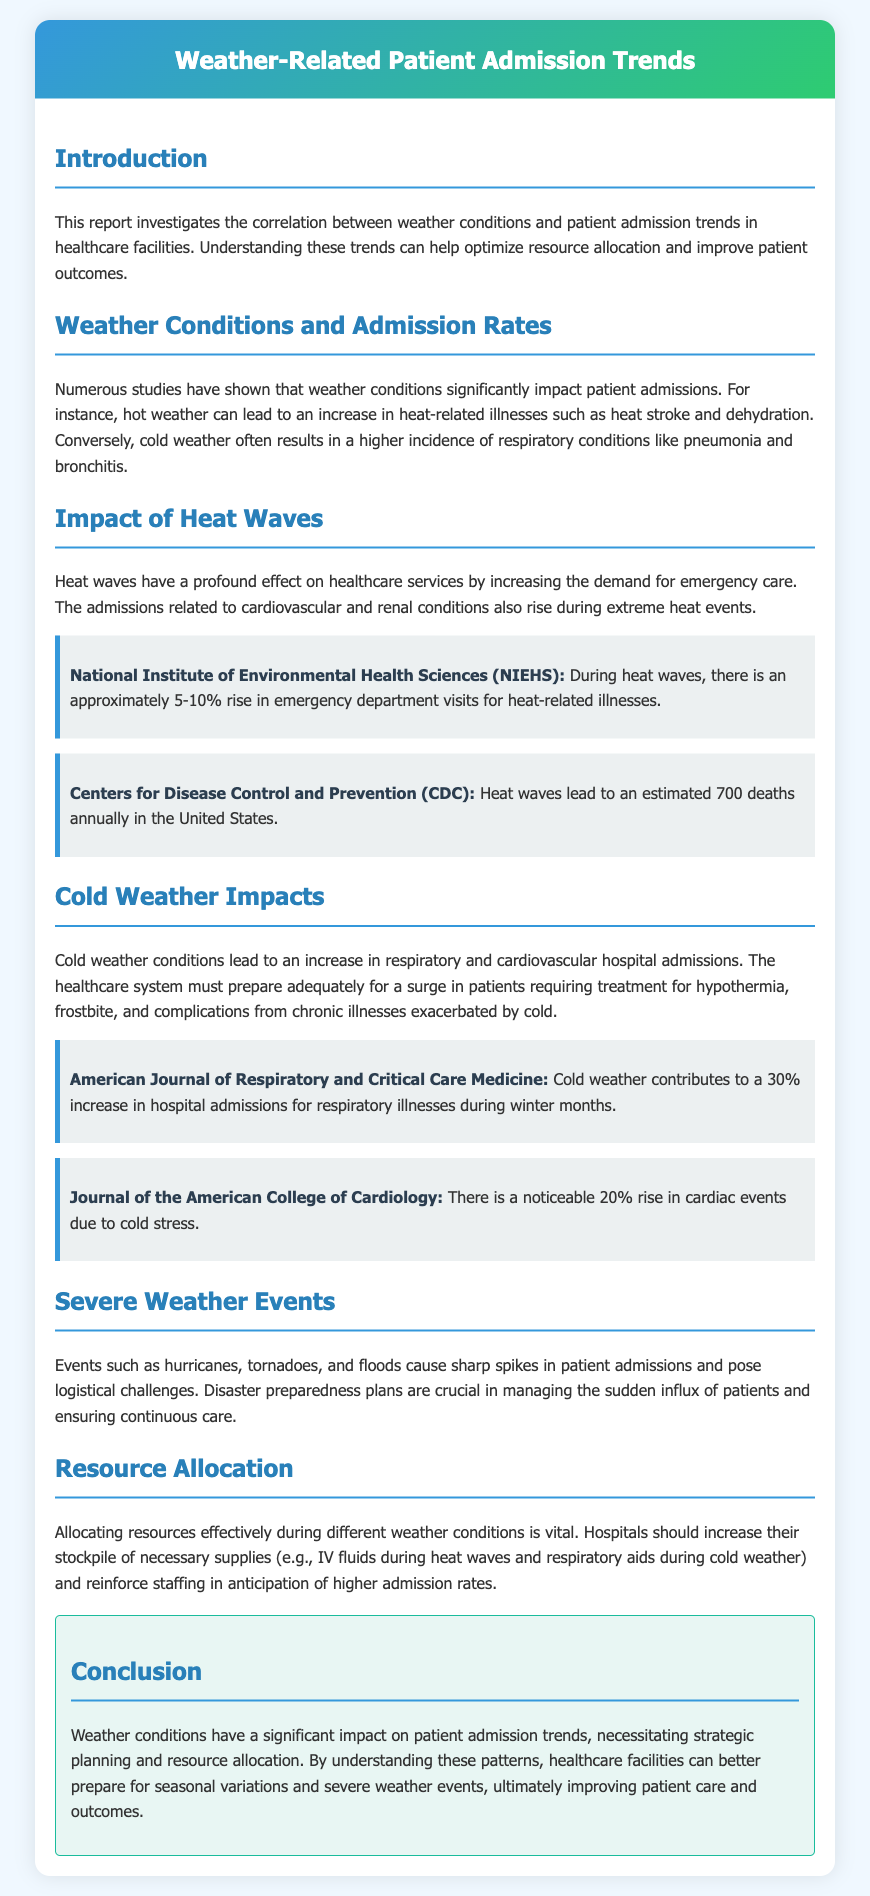What is the main focus of the report? The report primarily investigates the correlation between weather conditions and patient admission trends in healthcare facilities.
Answer: Correlation between weather conditions and patient admission trends What percentage increase in emergency department visits occurs during heat waves? The report states an approximate increase of 5-10% in emergency department visits for heat-related illnesses during heat waves.
Answer: 5-10% What is the annual death estimate due to heat waves in the United States? According to the CDC, heat waves lead to an estimated 700 deaths annually in the United States.
Answer: 700 deaths By what percentage does cold weather contribute to hospital admissions for respiratory illnesses? Cold weather contributes to a 30% increase in hospital admissions for respiratory illnesses during winter months.
Answer: 30% What types of severe weather events are discussed in the report? The report discusses hurricanes, tornadoes, and floods as severe weather events that cause spikes in patient admissions.
Answer: Hurricanes, tornadoes, floods What is a crucial strategy for managing sudden patient influx during severe weather events? The report emphasizes that disaster preparedness plans are crucial in managing the sudden influx of patients.
Answer: Disaster preparedness plans What should hospitals stockpile during heat waves? Hospitals should increase their stockpile of necessary supplies, particularly IV fluids during heat waves.
Answer: IV fluids What is the significance of understanding weather-related patient admission trends? Understanding these trends helps in strategic planning and resource allocation, ultimately improving patient care and outcomes.
Answer: Strategic planning and resource allocation 